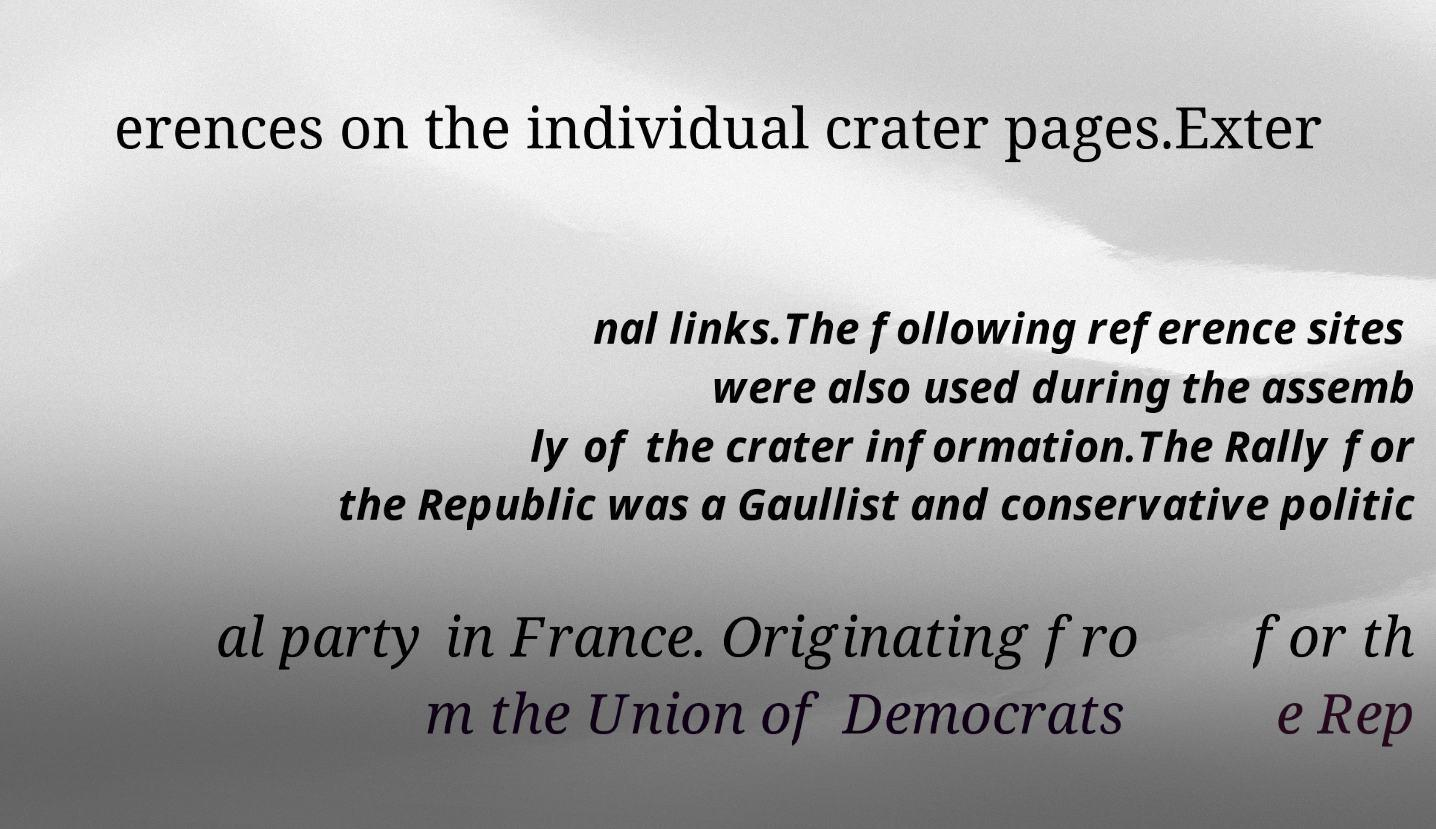For documentation purposes, I need the text within this image transcribed. Could you provide that? erences on the individual crater pages.Exter nal links.The following reference sites were also used during the assemb ly of the crater information.The Rally for the Republic was a Gaullist and conservative politic al party in France. Originating fro m the Union of Democrats for th e Rep 